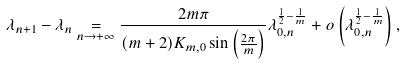<formula> <loc_0><loc_0><loc_500><loc_500>\lambda _ { n + 1 } - \lambda _ { n } \underset { n \to + \infty } { = } \frac { 2 m \pi } { ( m + 2 ) K _ { m , 0 } \sin \left ( \frac { 2 \pi } { m } \right ) } \lambda _ { 0 , n } ^ { \frac { 1 } { 2 } - \frac { 1 } { m } } + o \left ( \lambda _ { 0 , n } ^ { \frac { 1 } { 2 } - \frac { 1 } { m } } \right ) ,</formula> 